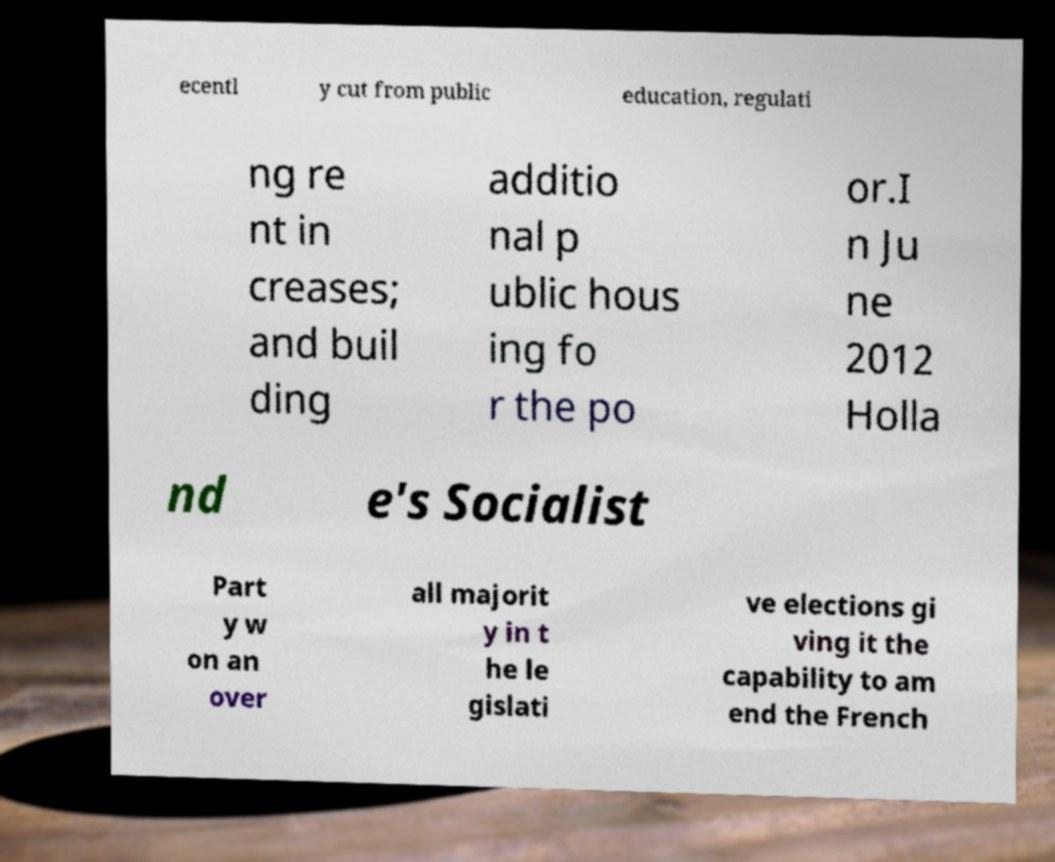Please identify and transcribe the text found in this image. ecentl y cut from public education, regulati ng re nt in creases; and buil ding additio nal p ublic hous ing fo r the po or.I n Ju ne 2012 Holla nd e's Socialist Part y w on an over all majorit y in t he le gislati ve elections gi ving it the capability to am end the French 